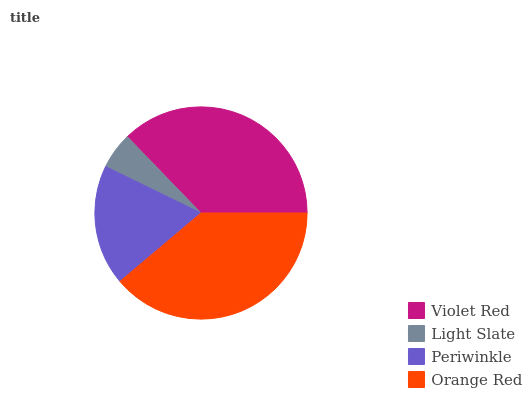Is Light Slate the minimum?
Answer yes or no. Yes. Is Orange Red the maximum?
Answer yes or no. Yes. Is Periwinkle the minimum?
Answer yes or no. No. Is Periwinkle the maximum?
Answer yes or no. No. Is Periwinkle greater than Light Slate?
Answer yes or no. Yes. Is Light Slate less than Periwinkle?
Answer yes or no. Yes. Is Light Slate greater than Periwinkle?
Answer yes or no. No. Is Periwinkle less than Light Slate?
Answer yes or no. No. Is Violet Red the high median?
Answer yes or no. Yes. Is Periwinkle the low median?
Answer yes or no. Yes. Is Orange Red the high median?
Answer yes or no. No. Is Orange Red the low median?
Answer yes or no. No. 